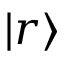<formula> <loc_0><loc_0><loc_500><loc_500>| r \rangle</formula> 